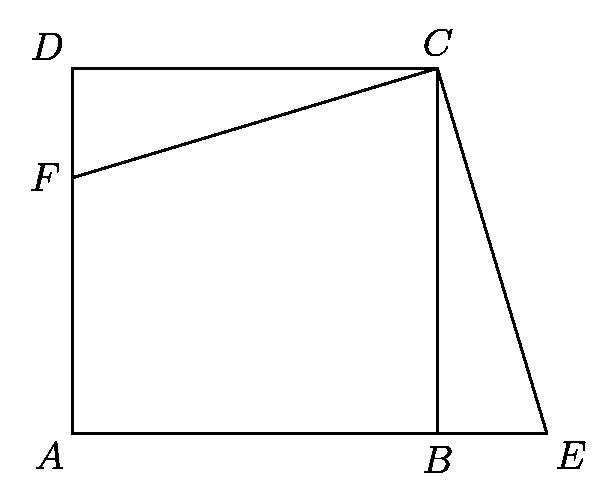Can you describe how the geometric properties of the square and triangle in the diagram might help in solving practical problems? The geometry of the square and triangle can be utilized to solve various practical problems involving spatial design, architectural planning, and engineering. For instance, understanding how to calculate the areas and lengths in this diagram can help design rooms or objects fitting specific area constraints, or can be used in creating sturdy and efficient triangular supports in structures. 